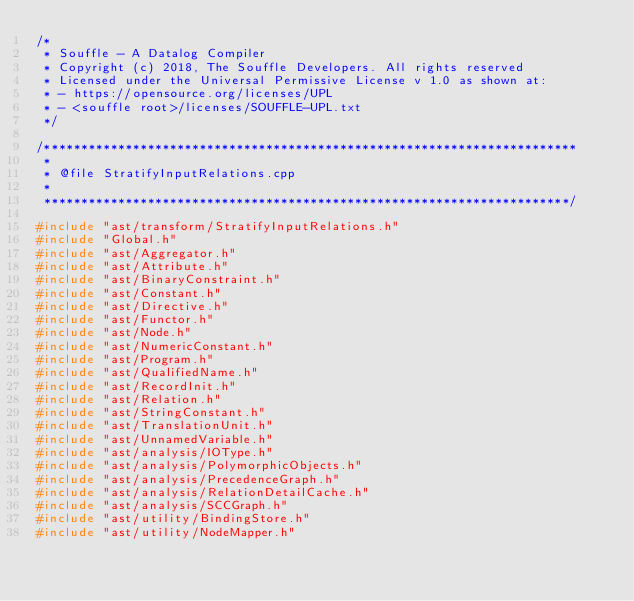<code> <loc_0><loc_0><loc_500><loc_500><_C++_>/*
 * Souffle - A Datalog Compiler
 * Copyright (c) 2018, The Souffle Developers. All rights reserved
 * Licensed under the Universal Permissive License v 1.0 as shown at:
 * - https://opensource.org/licenses/UPL
 * - <souffle root>/licenses/SOUFFLE-UPL.txt
 */

/************************************************************************
 *
 * @file StratifyInputRelations.cpp
 *
 ***********************************************************************/

#include "ast/transform/StratifyInputRelations.h"
#include "Global.h"
#include "ast/Aggregator.h"
#include "ast/Attribute.h"
#include "ast/BinaryConstraint.h"
#include "ast/Constant.h"
#include "ast/Directive.h"
#include "ast/Functor.h"
#include "ast/Node.h"
#include "ast/NumericConstant.h"
#include "ast/Program.h"
#include "ast/QualifiedName.h"
#include "ast/RecordInit.h"
#include "ast/Relation.h"
#include "ast/StringConstant.h"
#include "ast/TranslationUnit.h"
#include "ast/UnnamedVariable.h"
#include "ast/analysis/IOType.h"
#include "ast/analysis/PolymorphicObjects.h"
#include "ast/analysis/PrecedenceGraph.h"
#include "ast/analysis/RelationDetailCache.h"
#include "ast/analysis/SCCGraph.h"
#include "ast/utility/BindingStore.h"
#include "ast/utility/NodeMapper.h"</code> 